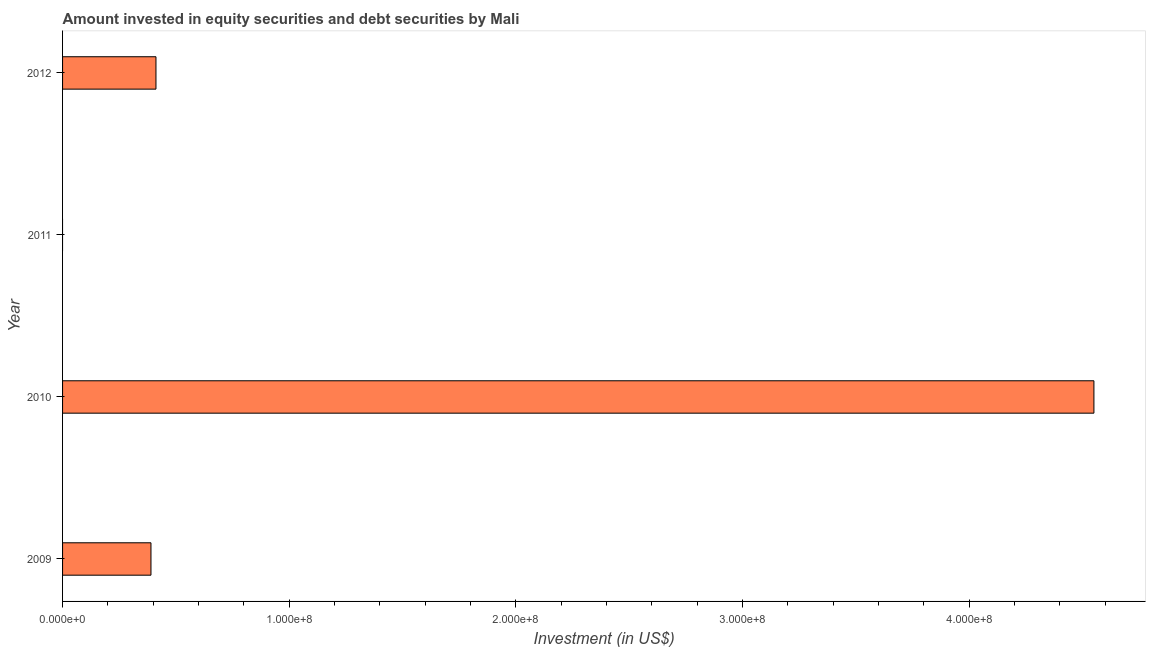Does the graph contain any zero values?
Your response must be concise. Yes. Does the graph contain grids?
Ensure brevity in your answer.  No. What is the title of the graph?
Offer a very short reply. Amount invested in equity securities and debt securities by Mali. What is the label or title of the X-axis?
Provide a succinct answer. Investment (in US$). What is the label or title of the Y-axis?
Keep it short and to the point. Year. What is the portfolio investment in 2011?
Provide a succinct answer. 0. Across all years, what is the maximum portfolio investment?
Make the answer very short. 4.55e+08. Across all years, what is the minimum portfolio investment?
Provide a short and direct response. 0. In which year was the portfolio investment maximum?
Give a very brief answer. 2010. What is the sum of the portfolio investment?
Your answer should be very brief. 5.35e+08. What is the difference between the portfolio investment in 2010 and 2012?
Your answer should be compact. 4.14e+08. What is the average portfolio investment per year?
Make the answer very short. 1.34e+08. What is the median portfolio investment?
Make the answer very short. 4.01e+07. What is the ratio of the portfolio investment in 2010 to that in 2012?
Offer a terse response. 11.04. Is the difference between the portfolio investment in 2009 and 2010 greater than the difference between any two years?
Give a very brief answer. No. What is the difference between the highest and the second highest portfolio investment?
Provide a succinct answer. 4.14e+08. What is the difference between the highest and the lowest portfolio investment?
Ensure brevity in your answer.  4.55e+08. In how many years, is the portfolio investment greater than the average portfolio investment taken over all years?
Your response must be concise. 1. How many bars are there?
Offer a very short reply. 3. What is the Investment (in US$) of 2009?
Keep it short and to the point. 3.90e+07. What is the Investment (in US$) of 2010?
Make the answer very short. 4.55e+08. What is the Investment (in US$) of 2011?
Your answer should be very brief. 0. What is the Investment (in US$) of 2012?
Provide a succinct answer. 4.12e+07. What is the difference between the Investment (in US$) in 2009 and 2010?
Keep it short and to the point. -4.16e+08. What is the difference between the Investment (in US$) in 2009 and 2012?
Ensure brevity in your answer.  -2.21e+06. What is the difference between the Investment (in US$) in 2010 and 2012?
Provide a succinct answer. 4.14e+08. What is the ratio of the Investment (in US$) in 2009 to that in 2010?
Make the answer very short. 0.09. What is the ratio of the Investment (in US$) in 2009 to that in 2012?
Provide a short and direct response. 0.95. What is the ratio of the Investment (in US$) in 2010 to that in 2012?
Give a very brief answer. 11.04. 